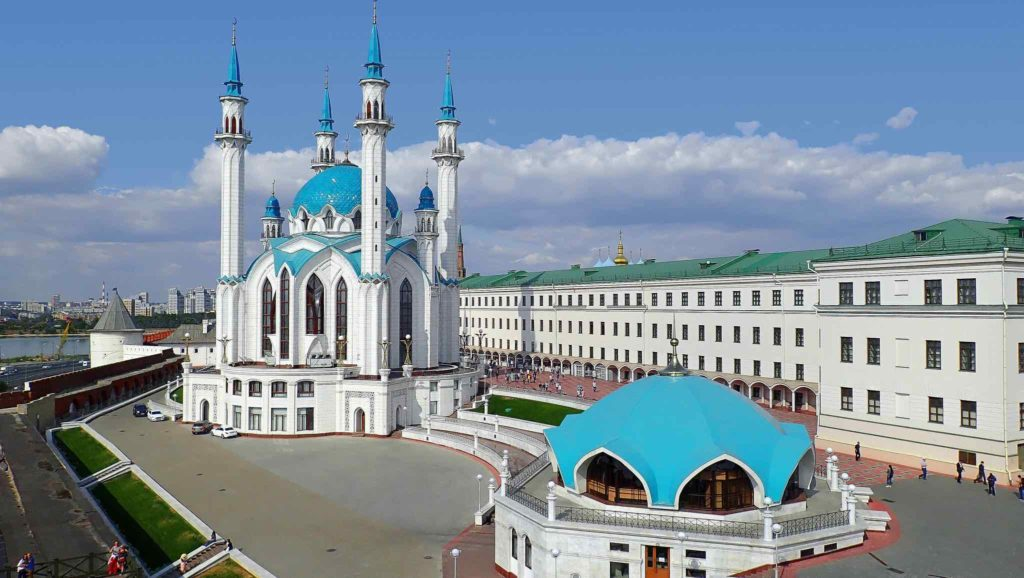If this scene were part of a fantasy world, what kind of mythical creatures might inhabit it? In a fantasy world, the Kazan Kremlin could be home to a variety of mythical creatures that add a touch of magic to the scene. You might encounter majestic griffins perched atop the minarets of the Kul Sharif Mosque, keeping a watchful eye over the city. Beneath the archways of the Presidential Palace, you could find wise old centaurs offering guidance to visitors and scholars who come seeking knowledge. On the lush green lawns, playful fae and sprites might flit about, creating a peaceful and enchanting ambience. Dragons could be seen soaring above, their scales mirroring the colors of the buildings below, embodying the strength and mystique of this fantastical realm. The walls of the Kremlin might be guarded by stone golems, ancient protectors awakened by an old magic to defend the sacred grounds. 